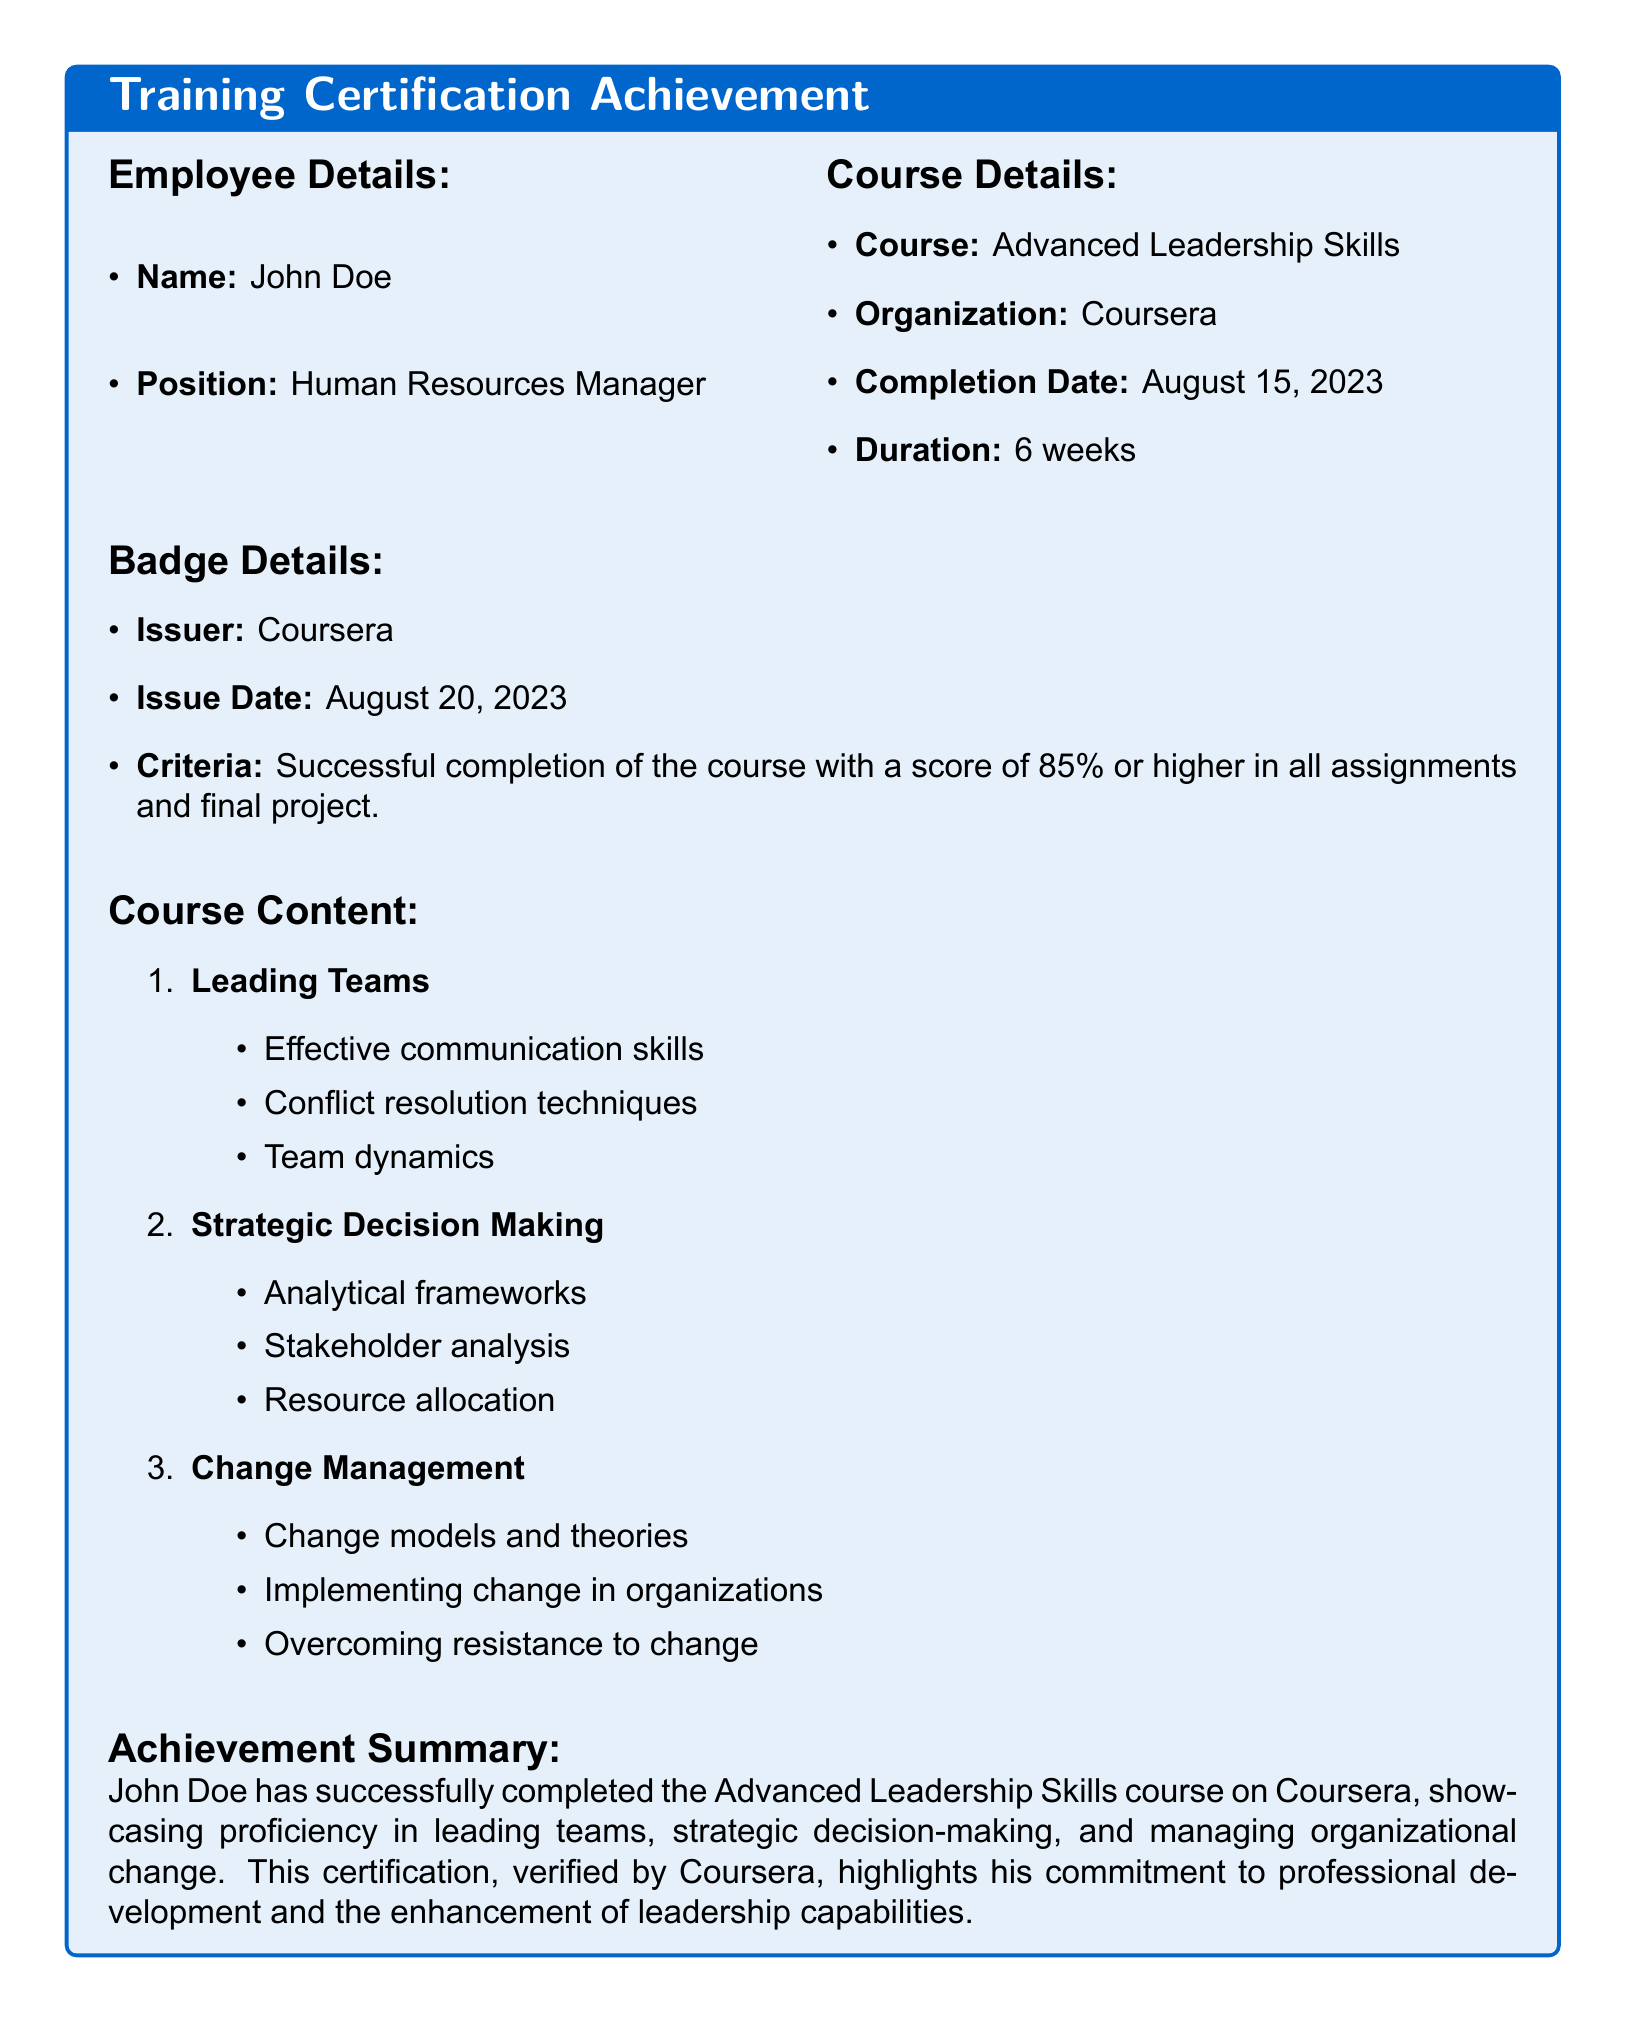What is the name of the employee? The document includes the employee's name in the "Employee Details" section.
Answer: John Doe What is the position of the employee? The position of the employee is listed in the "Employee Details" section of the document.
Answer: Human Resources Manager What is the course name? The document provides the course name under "Course Details".
Answer: Advanced Leadership Skills When was the course completed? The completion date is specified in the "Course Details" section of the document.
Answer: August 15, 2023 What is the issuer of the badge? The issuer of the badge is mentioned in the "Badge Details" section.
Answer: Coursera What was the score required for course completion? The criteria for earning the badge includes a specific score mentioned in the "Badge Details".
Answer: 85% How long did the course last? The duration of the course is indicated in the "Course Details" section of the document.
Answer: 6 weeks What are the three main topics covered in the course? The course content lists several topics under a numbered format; the three main ones are summarized.
Answer: Leading Teams, Strategic Decision Making, Change Management What is the issue date of the badge? The document states the issue date in the "Badge Details" section.
Answer: August 20, 2023 